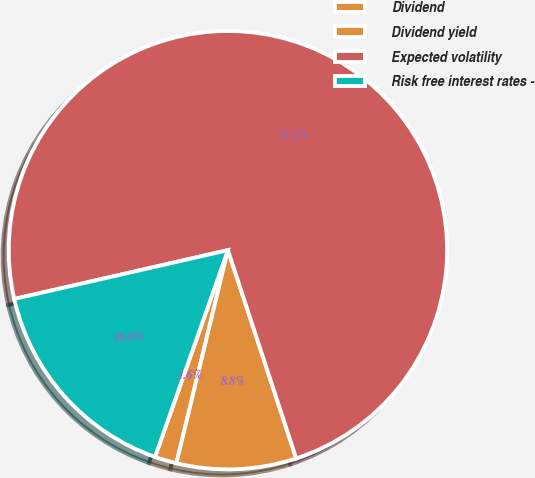Convert chart. <chart><loc_0><loc_0><loc_500><loc_500><pie_chart><fcel>Dividend<fcel>Dividend yield<fcel>Expected volatility<fcel>Risk free interest rates -<nl><fcel>1.62%<fcel>8.82%<fcel>73.53%<fcel>16.03%<nl></chart> 